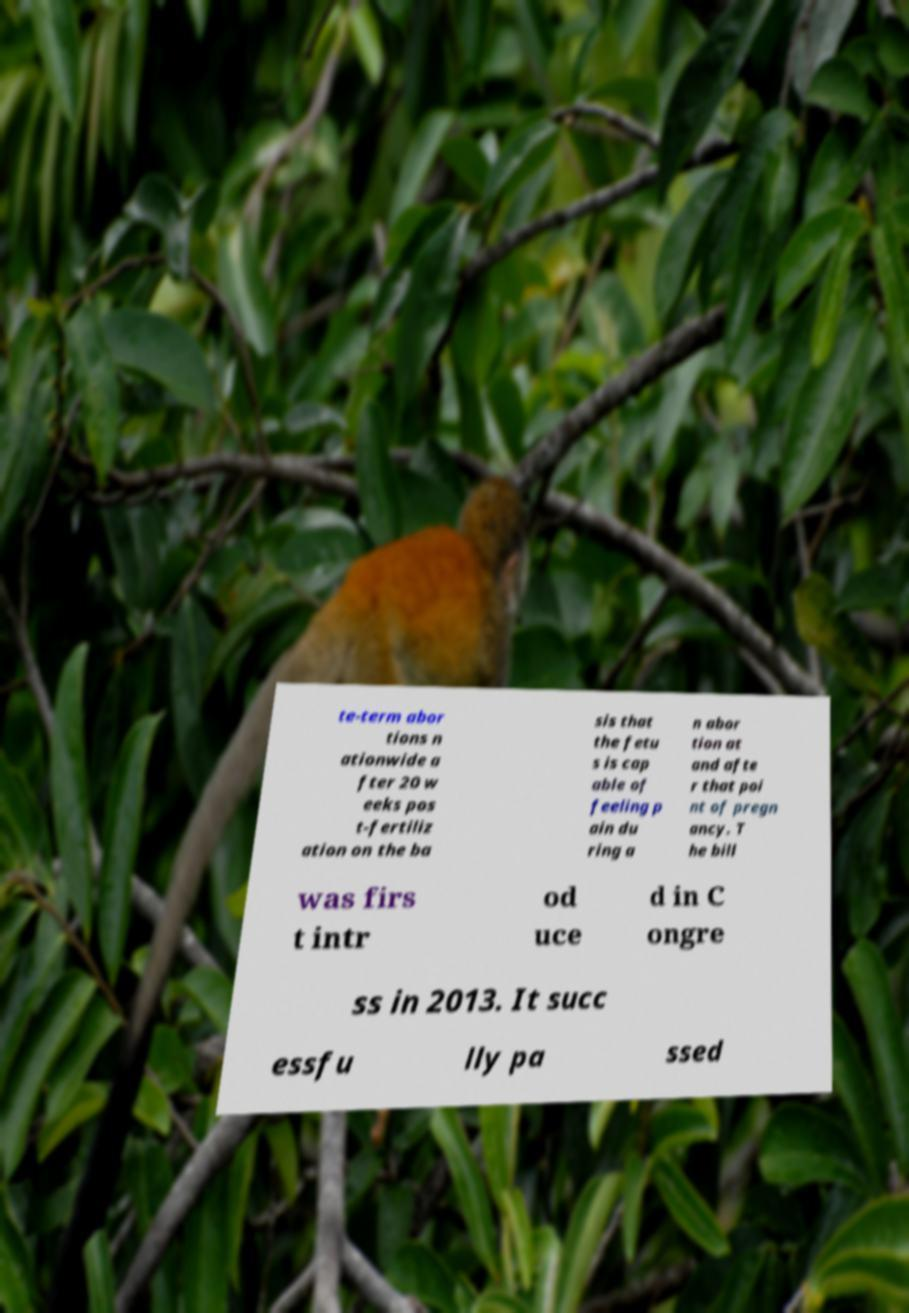Could you assist in decoding the text presented in this image and type it out clearly? te-term abor tions n ationwide a fter 20 w eeks pos t-fertiliz ation on the ba sis that the fetu s is cap able of feeling p ain du ring a n abor tion at and afte r that poi nt of pregn ancy. T he bill was firs t intr od uce d in C ongre ss in 2013. It succ essfu lly pa ssed 